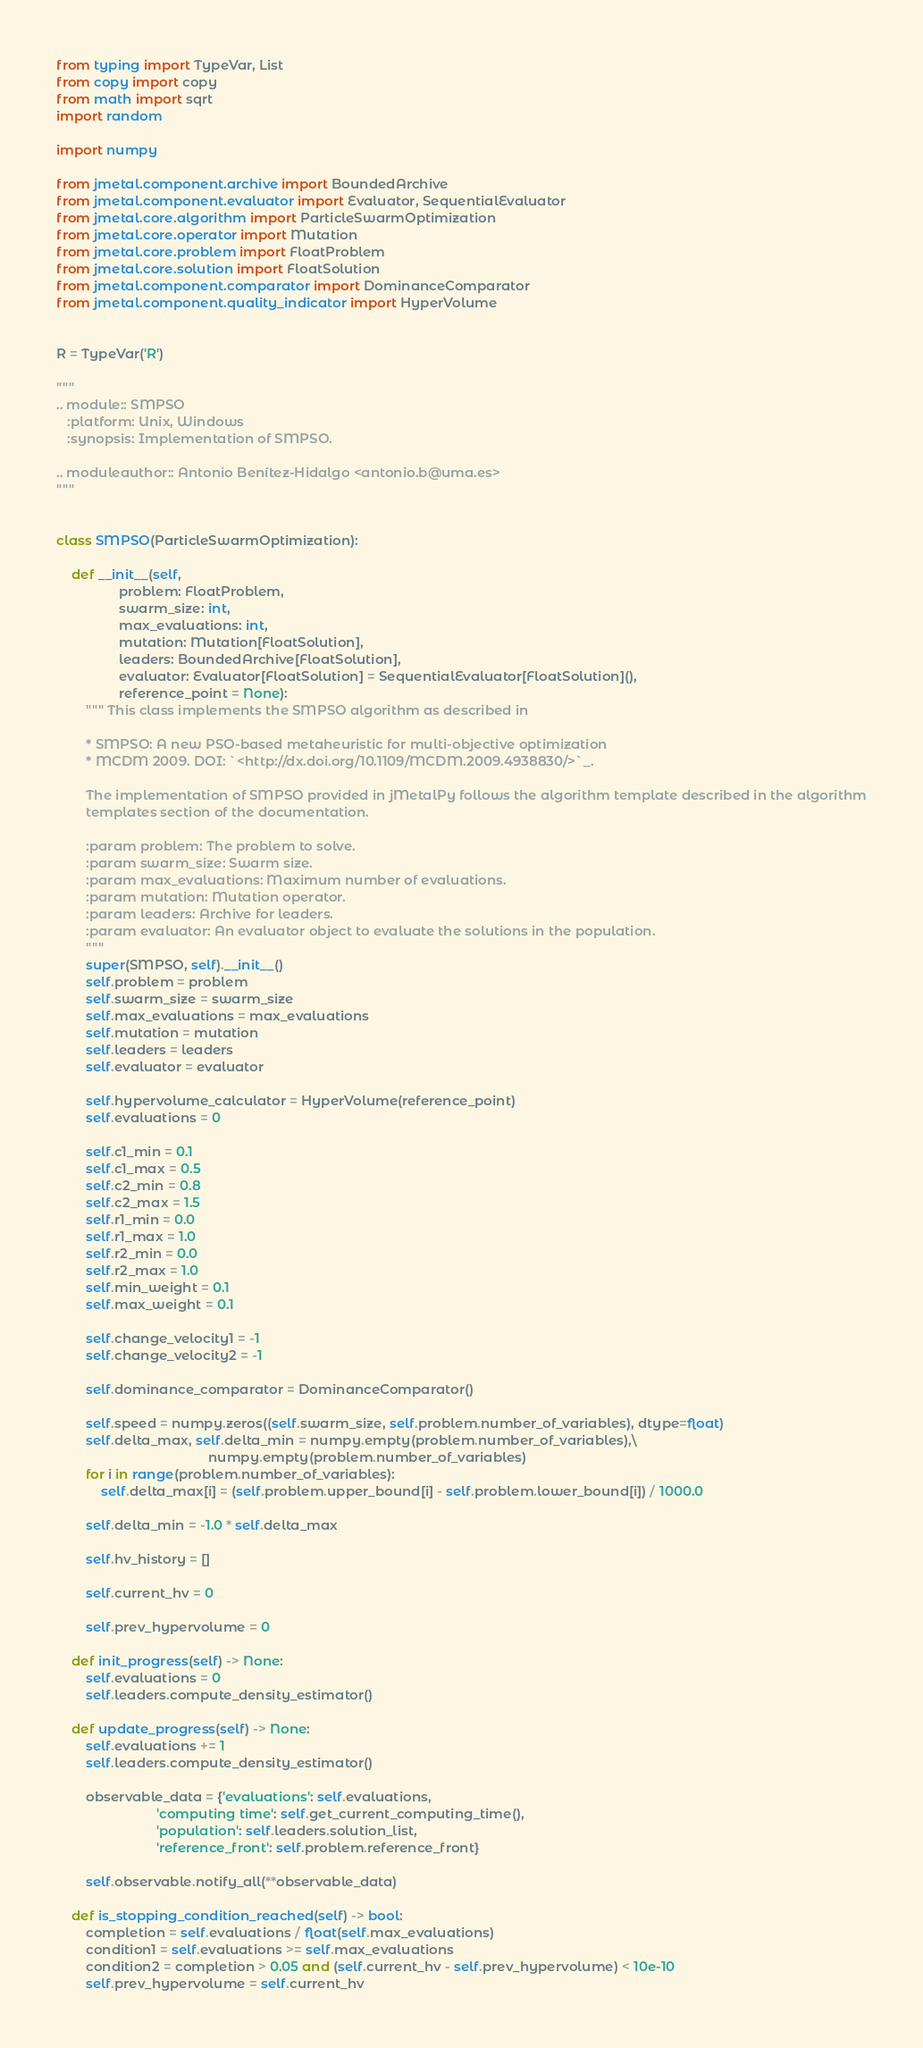<code> <loc_0><loc_0><loc_500><loc_500><_Python_>from typing import TypeVar, List
from copy import copy
from math import sqrt
import random

import numpy

from jmetal.component.archive import BoundedArchive
from jmetal.component.evaluator import Evaluator, SequentialEvaluator
from jmetal.core.algorithm import ParticleSwarmOptimization
from jmetal.core.operator import Mutation
from jmetal.core.problem import FloatProblem
from jmetal.core.solution import FloatSolution
from jmetal.component.comparator import DominanceComparator
from jmetal.component.quality_indicator import HyperVolume


R = TypeVar('R')

"""
.. module:: SMPSO
   :platform: Unix, Windows
   :synopsis: Implementation of SMPSO.

.. moduleauthor:: Antonio Benítez-Hidalgo <antonio.b@uma.es>
"""


class SMPSO(ParticleSwarmOptimization):

    def __init__(self,
                 problem: FloatProblem,
                 swarm_size: int,
                 max_evaluations: int,
                 mutation: Mutation[FloatSolution],
                 leaders: BoundedArchive[FloatSolution],
                 evaluator: Evaluator[FloatSolution] = SequentialEvaluator[FloatSolution](),
                 reference_point = None):
        """ This class implements the SMPSO algorithm as described in

        * SMPSO: A new PSO-based metaheuristic for multi-objective optimization
        * MCDM 2009. DOI: `<http://dx.doi.org/10.1109/MCDM.2009.4938830/>`_.

        The implementation of SMPSO provided in jMetalPy follows the algorithm template described in the algorithm
        templates section of the documentation.

        :param problem: The problem to solve.
        :param swarm_size: Swarm size.
        :param max_evaluations: Maximum number of evaluations.
        :param mutation: Mutation operator.
        :param leaders: Archive for leaders.
        :param evaluator: An evaluator object to evaluate the solutions in the population.
        """
        super(SMPSO, self).__init__()
        self.problem = problem
        self.swarm_size = swarm_size
        self.max_evaluations = max_evaluations
        self.mutation = mutation
        self.leaders = leaders
        self.evaluator = evaluator

        self.hypervolume_calculator = HyperVolume(reference_point)
        self.evaluations = 0

        self.c1_min = 0.1
        self.c1_max = 0.5
        self.c2_min = 0.8
        self.c2_max = 1.5
        self.r1_min = 0.0
        self.r1_max = 1.0
        self.r2_min = 0.0
        self.r2_max = 1.0
        self.min_weight = 0.1
        self.max_weight = 0.1

        self.change_velocity1 = -1
        self.change_velocity2 = -1

        self.dominance_comparator = DominanceComparator()

        self.speed = numpy.zeros((self.swarm_size, self.problem.number_of_variables), dtype=float)
        self.delta_max, self.delta_min = numpy.empty(problem.number_of_variables),\
                                         numpy.empty(problem.number_of_variables)
        for i in range(problem.number_of_variables):
            self.delta_max[i] = (self.problem.upper_bound[i] - self.problem.lower_bound[i]) / 1000.0

        self.delta_min = -1.0 * self.delta_max

        self.hv_history = []

        self.current_hv = 0

        self.prev_hypervolume = 0

    def init_progress(self) -> None:
        self.evaluations = 0
        self.leaders.compute_density_estimator()

    def update_progress(self) -> None:
        self.evaluations += 1
        self.leaders.compute_density_estimator()

        observable_data = {'evaluations': self.evaluations,
                           'computing time': self.get_current_computing_time(),
                           'population': self.leaders.solution_list,
                           'reference_front': self.problem.reference_front}

        self.observable.notify_all(**observable_data)

    def is_stopping_condition_reached(self) -> bool:
        completion = self.evaluations / float(self.max_evaluations)
        condition1 = self.evaluations >= self.max_evaluations
        condition2 = completion > 0.05 and (self.current_hv - self.prev_hypervolume) < 10e-10
        self.prev_hypervolume = self.current_hv</code> 